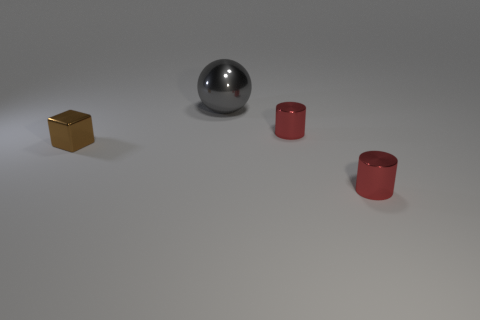Add 4 big brown matte cylinders. How many objects exist? 8 Subtract all blocks. How many objects are left? 3 Add 4 tiny red things. How many tiny red things are left? 6 Add 3 large spheres. How many large spheres exist? 4 Subtract 0 green cylinders. How many objects are left? 4 Subtract all blocks. Subtract all large spheres. How many objects are left? 2 